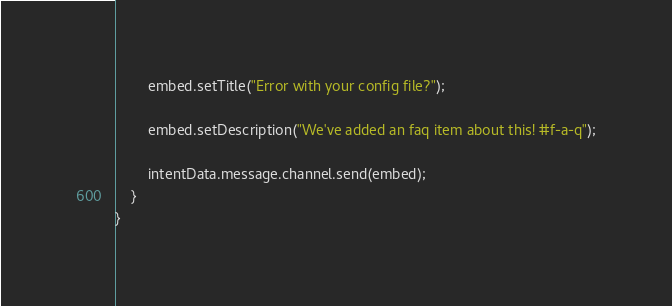<code> <loc_0><loc_0><loc_500><loc_500><_TypeScript_>
        embed.setTitle("Error with your config file?");

        embed.setDescription("We've added an faq item about this! #f-a-q");

        intentData.message.channel.send(embed);
    }
}</code> 